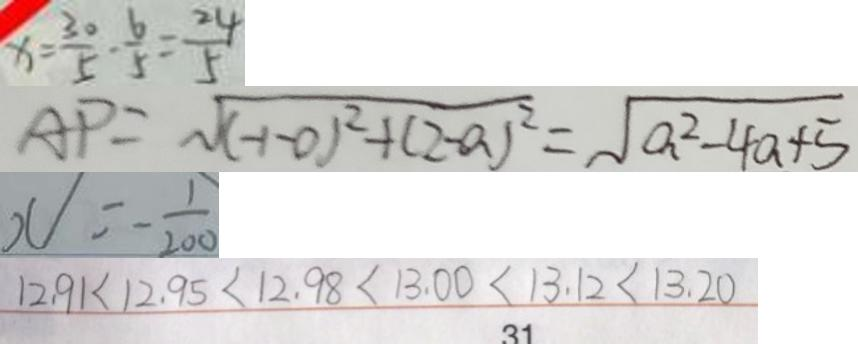<formula> <loc_0><loc_0><loc_500><loc_500>x = \frac { 3 0 } { 5 } - \frac { 6 } { 5 } = \frac { 2 4 } { 5 } 
 A P = \sqrt { ( - 1 - 0 ) ^ { 2 } + ( 2 - a ) ^ { 2 } } = \sqrt { a ^ { 2 } - 4 a + 5 } 
 x = - \frac { 1 } { 2 0 0 } 
 1 2 . 9 1 < 1 2 . 9 5 < 1 2 . 9 8 < 1 3 . 0 0 < 1 3 . 1 2 < 1 3 . 2 0</formula> 